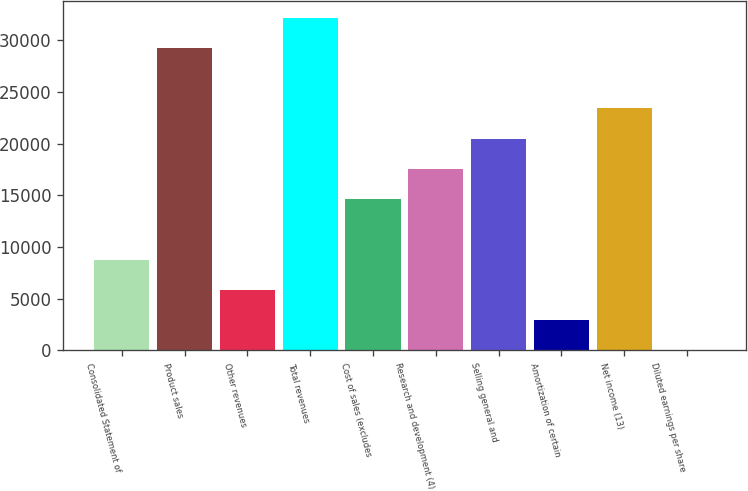<chart> <loc_0><loc_0><loc_500><loc_500><bar_chart><fcel>Consolidated Statement of<fcel>Product sales<fcel>Other revenues<fcel>Total revenues<fcel>Cost of sales (excludes<fcel>Research and development (4)<fcel>Selling general and<fcel>Amortization of certain<fcel>Net income (13)<fcel>Diluted earnings per share<nl><fcel>8777.63<fcel>29252<fcel>5852.72<fcel>32176.9<fcel>14627.5<fcel>17552.4<fcel>20477.3<fcel>2927.81<fcel>23402.2<fcel>2.9<nl></chart> 